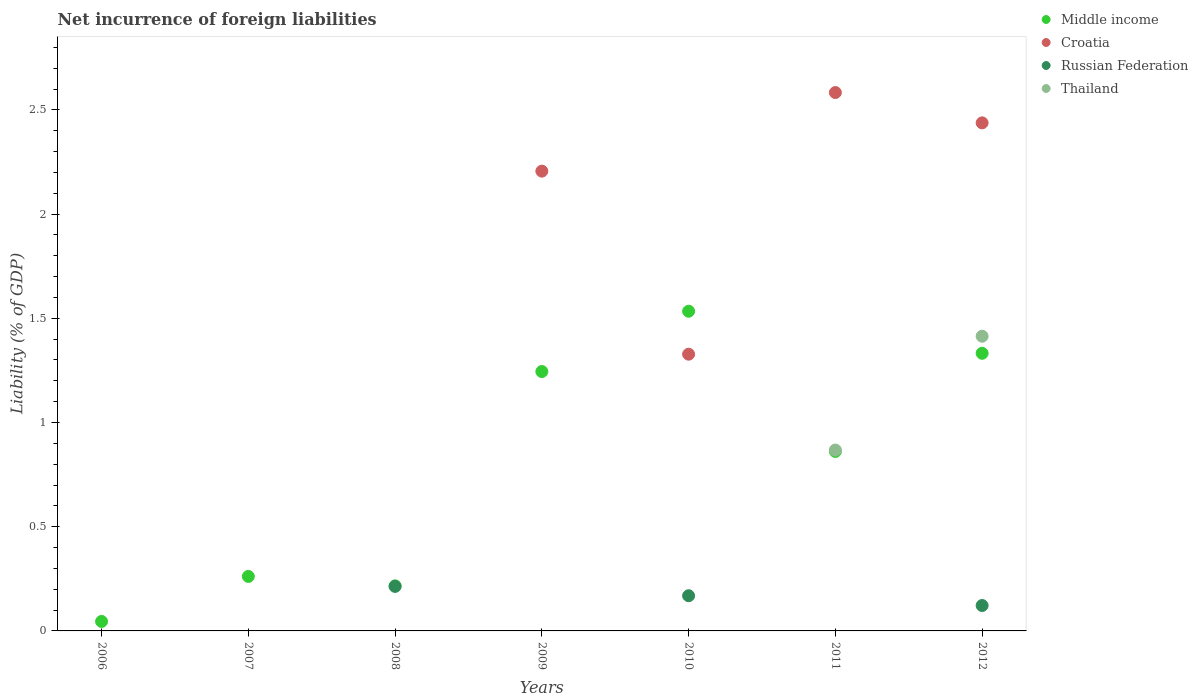What is the net incurrence of foreign liabilities in Thailand in 2011?
Offer a very short reply. 0.87. Across all years, what is the maximum net incurrence of foreign liabilities in Middle income?
Offer a very short reply. 1.53. In which year was the net incurrence of foreign liabilities in Thailand maximum?
Offer a terse response. 2012. What is the total net incurrence of foreign liabilities in Russian Federation in the graph?
Your answer should be compact. 0.5. What is the difference between the net incurrence of foreign liabilities in Middle income in 2008 and that in 2011?
Offer a very short reply. -0.65. What is the difference between the net incurrence of foreign liabilities in Thailand in 2011 and the net incurrence of foreign liabilities in Russian Federation in 2007?
Provide a succinct answer. 0.87. What is the average net incurrence of foreign liabilities in Middle income per year?
Offer a terse response. 0.79. In the year 2010, what is the difference between the net incurrence of foreign liabilities in Croatia and net incurrence of foreign liabilities in Middle income?
Give a very brief answer. -0.21. What is the ratio of the net incurrence of foreign liabilities in Croatia in 2009 to that in 2010?
Provide a succinct answer. 1.66. Is the difference between the net incurrence of foreign liabilities in Croatia in 2010 and 2012 greater than the difference between the net incurrence of foreign liabilities in Middle income in 2010 and 2012?
Your answer should be compact. No. What is the difference between the highest and the second highest net incurrence of foreign liabilities in Croatia?
Your response must be concise. 0.15. What is the difference between the highest and the lowest net incurrence of foreign liabilities in Thailand?
Your answer should be very brief. 1.41. In how many years, is the net incurrence of foreign liabilities in Russian Federation greater than the average net incurrence of foreign liabilities in Russian Federation taken over all years?
Make the answer very short. 3. Is it the case that in every year, the sum of the net incurrence of foreign liabilities in Thailand and net incurrence of foreign liabilities in Croatia  is greater than the sum of net incurrence of foreign liabilities in Middle income and net incurrence of foreign liabilities in Russian Federation?
Provide a short and direct response. No. Does the net incurrence of foreign liabilities in Russian Federation monotonically increase over the years?
Keep it short and to the point. No. Is the net incurrence of foreign liabilities in Middle income strictly greater than the net incurrence of foreign liabilities in Croatia over the years?
Your answer should be compact. No. How many dotlines are there?
Ensure brevity in your answer.  4. What is the difference between two consecutive major ticks on the Y-axis?
Your answer should be compact. 0.5. Are the values on the major ticks of Y-axis written in scientific E-notation?
Your response must be concise. No. Does the graph contain any zero values?
Provide a succinct answer. Yes. Where does the legend appear in the graph?
Keep it short and to the point. Top right. How many legend labels are there?
Keep it short and to the point. 4. What is the title of the graph?
Provide a succinct answer. Net incurrence of foreign liabilities. What is the label or title of the X-axis?
Ensure brevity in your answer.  Years. What is the label or title of the Y-axis?
Keep it short and to the point. Liability (% of GDP). What is the Liability (% of GDP) of Middle income in 2006?
Your answer should be compact. 0.05. What is the Liability (% of GDP) in Middle income in 2007?
Provide a short and direct response. 0.26. What is the Liability (% of GDP) of Thailand in 2007?
Provide a short and direct response. 0. What is the Liability (% of GDP) of Middle income in 2008?
Your answer should be compact. 0.22. What is the Liability (% of GDP) of Croatia in 2008?
Ensure brevity in your answer.  0. What is the Liability (% of GDP) of Russian Federation in 2008?
Make the answer very short. 0.21. What is the Liability (% of GDP) of Middle income in 2009?
Keep it short and to the point. 1.24. What is the Liability (% of GDP) in Croatia in 2009?
Keep it short and to the point. 2.21. What is the Liability (% of GDP) of Russian Federation in 2009?
Your response must be concise. 0. What is the Liability (% of GDP) of Thailand in 2009?
Your answer should be compact. 0. What is the Liability (% of GDP) in Middle income in 2010?
Give a very brief answer. 1.53. What is the Liability (% of GDP) of Croatia in 2010?
Keep it short and to the point. 1.33. What is the Liability (% of GDP) in Russian Federation in 2010?
Offer a very short reply. 0.17. What is the Liability (% of GDP) in Thailand in 2010?
Make the answer very short. 0. What is the Liability (% of GDP) in Middle income in 2011?
Ensure brevity in your answer.  0.86. What is the Liability (% of GDP) of Croatia in 2011?
Your response must be concise. 2.58. What is the Liability (% of GDP) in Russian Federation in 2011?
Offer a terse response. 0. What is the Liability (% of GDP) of Thailand in 2011?
Offer a very short reply. 0.87. What is the Liability (% of GDP) in Middle income in 2012?
Your answer should be compact. 1.33. What is the Liability (% of GDP) of Croatia in 2012?
Offer a very short reply. 2.44. What is the Liability (% of GDP) in Russian Federation in 2012?
Provide a short and direct response. 0.12. What is the Liability (% of GDP) in Thailand in 2012?
Provide a short and direct response. 1.41. Across all years, what is the maximum Liability (% of GDP) in Middle income?
Provide a short and direct response. 1.53. Across all years, what is the maximum Liability (% of GDP) of Croatia?
Make the answer very short. 2.58. Across all years, what is the maximum Liability (% of GDP) in Russian Federation?
Offer a very short reply. 0.21. Across all years, what is the maximum Liability (% of GDP) of Thailand?
Ensure brevity in your answer.  1.41. Across all years, what is the minimum Liability (% of GDP) in Middle income?
Provide a succinct answer. 0.05. Across all years, what is the minimum Liability (% of GDP) in Thailand?
Provide a short and direct response. 0. What is the total Liability (% of GDP) in Middle income in the graph?
Offer a very short reply. 5.5. What is the total Liability (% of GDP) of Croatia in the graph?
Make the answer very short. 8.56. What is the total Liability (% of GDP) in Russian Federation in the graph?
Offer a terse response. 0.5. What is the total Liability (% of GDP) in Thailand in the graph?
Keep it short and to the point. 2.28. What is the difference between the Liability (% of GDP) of Middle income in 2006 and that in 2007?
Your answer should be compact. -0.22. What is the difference between the Liability (% of GDP) of Middle income in 2006 and that in 2008?
Make the answer very short. -0.17. What is the difference between the Liability (% of GDP) in Middle income in 2006 and that in 2009?
Your response must be concise. -1.2. What is the difference between the Liability (% of GDP) in Middle income in 2006 and that in 2010?
Your answer should be compact. -1.49. What is the difference between the Liability (% of GDP) in Middle income in 2006 and that in 2011?
Your answer should be compact. -0.82. What is the difference between the Liability (% of GDP) in Middle income in 2006 and that in 2012?
Provide a short and direct response. -1.29. What is the difference between the Liability (% of GDP) of Middle income in 2007 and that in 2008?
Offer a very short reply. 0.05. What is the difference between the Liability (% of GDP) in Middle income in 2007 and that in 2009?
Offer a very short reply. -0.98. What is the difference between the Liability (% of GDP) of Middle income in 2007 and that in 2010?
Your answer should be compact. -1.27. What is the difference between the Liability (% of GDP) of Middle income in 2007 and that in 2011?
Your answer should be compact. -0.6. What is the difference between the Liability (% of GDP) of Middle income in 2007 and that in 2012?
Your answer should be compact. -1.07. What is the difference between the Liability (% of GDP) of Middle income in 2008 and that in 2009?
Your answer should be very brief. -1.03. What is the difference between the Liability (% of GDP) of Middle income in 2008 and that in 2010?
Provide a short and direct response. -1.32. What is the difference between the Liability (% of GDP) of Russian Federation in 2008 and that in 2010?
Provide a short and direct response. 0.04. What is the difference between the Liability (% of GDP) in Middle income in 2008 and that in 2011?
Your answer should be compact. -0.65. What is the difference between the Liability (% of GDP) in Middle income in 2008 and that in 2012?
Your answer should be compact. -1.12. What is the difference between the Liability (% of GDP) of Russian Federation in 2008 and that in 2012?
Ensure brevity in your answer.  0.09. What is the difference between the Liability (% of GDP) of Middle income in 2009 and that in 2010?
Ensure brevity in your answer.  -0.29. What is the difference between the Liability (% of GDP) in Croatia in 2009 and that in 2010?
Offer a very short reply. 0.88. What is the difference between the Liability (% of GDP) in Middle income in 2009 and that in 2011?
Offer a terse response. 0.38. What is the difference between the Liability (% of GDP) of Croatia in 2009 and that in 2011?
Give a very brief answer. -0.38. What is the difference between the Liability (% of GDP) of Middle income in 2009 and that in 2012?
Make the answer very short. -0.09. What is the difference between the Liability (% of GDP) in Croatia in 2009 and that in 2012?
Keep it short and to the point. -0.23. What is the difference between the Liability (% of GDP) of Middle income in 2010 and that in 2011?
Offer a terse response. 0.67. What is the difference between the Liability (% of GDP) in Croatia in 2010 and that in 2011?
Offer a terse response. -1.26. What is the difference between the Liability (% of GDP) of Middle income in 2010 and that in 2012?
Your answer should be compact. 0.2. What is the difference between the Liability (% of GDP) in Croatia in 2010 and that in 2012?
Your response must be concise. -1.11. What is the difference between the Liability (% of GDP) in Russian Federation in 2010 and that in 2012?
Your answer should be compact. 0.05. What is the difference between the Liability (% of GDP) in Middle income in 2011 and that in 2012?
Offer a terse response. -0.47. What is the difference between the Liability (% of GDP) of Croatia in 2011 and that in 2012?
Your answer should be very brief. 0.15. What is the difference between the Liability (% of GDP) of Thailand in 2011 and that in 2012?
Keep it short and to the point. -0.55. What is the difference between the Liability (% of GDP) in Middle income in 2006 and the Liability (% of GDP) in Russian Federation in 2008?
Your answer should be compact. -0.17. What is the difference between the Liability (% of GDP) in Middle income in 2006 and the Liability (% of GDP) in Croatia in 2009?
Offer a very short reply. -2.16. What is the difference between the Liability (% of GDP) in Middle income in 2006 and the Liability (% of GDP) in Croatia in 2010?
Keep it short and to the point. -1.28. What is the difference between the Liability (% of GDP) in Middle income in 2006 and the Liability (% of GDP) in Russian Federation in 2010?
Keep it short and to the point. -0.12. What is the difference between the Liability (% of GDP) of Middle income in 2006 and the Liability (% of GDP) of Croatia in 2011?
Ensure brevity in your answer.  -2.54. What is the difference between the Liability (% of GDP) in Middle income in 2006 and the Liability (% of GDP) in Thailand in 2011?
Your answer should be very brief. -0.82. What is the difference between the Liability (% of GDP) of Middle income in 2006 and the Liability (% of GDP) of Croatia in 2012?
Your answer should be compact. -2.39. What is the difference between the Liability (% of GDP) of Middle income in 2006 and the Liability (% of GDP) of Russian Federation in 2012?
Provide a succinct answer. -0.08. What is the difference between the Liability (% of GDP) of Middle income in 2006 and the Liability (% of GDP) of Thailand in 2012?
Give a very brief answer. -1.37. What is the difference between the Liability (% of GDP) in Middle income in 2007 and the Liability (% of GDP) in Russian Federation in 2008?
Provide a short and direct response. 0.05. What is the difference between the Liability (% of GDP) in Middle income in 2007 and the Liability (% of GDP) in Croatia in 2009?
Your answer should be compact. -1.94. What is the difference between the Liability (% of GDP) in Middle income in 2007 and the Liability (% of GDP) in Croatia in 2010?
Give a very brief answer. -1.07. What is the difference between the Liability (% of GDP) in Middle income in 2007 and the Liability (% of GDP) in Russian Federation in 2010?
Your response must be concise. 0.09. What is the difference between the Liability (% of GDP) of Middle income in 2007 and the Liability (% of GDP) of Croatia in 2011?
Keep it short and to the point. -2.32. What is the difference between the Liability (% of GDP) of Middle income in 2007 and the Liability (% of GDP) of Thailand in 2011?
Keep it short and to the point. -0.61. What is the difference between the Liability (% of GDP) of Middle income in 2007 and the Liability (% of GDP) of Croatia in 2012?
Provide a short and direct response. -2.18. What is the difference between the Liability (% of GDP) in Middle income in 2007 and the Liability (% of GDP) in Russian Federation in 2012?
Your answer should be compact. 0.14. What is the difference between the Liability (% of GDP) in Middle income in 2007 and the Liability (% of GDP) in Thailand in 2012?
Make the answer very short. -1.15. What is the difference between the Liability (% of GDP) of Middle income in 2008 and the Liability (% of GDP) of Croatia in 2009?
Give a very brief answer. -1.99. What is the difference between the Liability (% of GDP) in Middle income in 2008 and the Liability (% of GDP) in Croatia in 2010?
Offer a very short reply. -1.11. What is the difference between the Liability (% of GDP) of Middle income in 2008 and the Liability (% of GDP) of Russian Federation in 2010?
Offer a terse response. 0.05. What is the difference between the Liability (% of GDP) of Middle income in 2008 and the Liability (% of GDP) of Croatia in 2011?
Your answer should be compact. -2.37. What is the difference between the Liability (% of GDP) in Middle income in 2008 and the Liability (% of GDP) in Thailand in 2011?
Keep it short and to the point. -0.65. What is the difference between the Liability (% of GDP) in Russian Federation in 2008 and the Liability (% of GDP) in Thailand in 2011?
Keep it short and to the point. -0.65. What is the difference between the Liability (% of GDP) in Middle income in 2008 and the Liability (% of GDP) in Croatia in 2012?
Provide a succinct answer. -2.22. What is the difference between the Liability (% of GDP) of Middle income in 2008 and the Liability (% of GDP) of Russian Federation in 2012?
Keep it short and to the point. 0.09. What is the difference between the Liability (% of GDP) in Middle income in 2008 and the Liability (% of GDP) in Thailand in 2012?
Your response must be concise. -1.2. What is the difference between the Liability (% of GDP) of Russian Federation in 2008 and the Liability (% of GDP) of Thailand in 2012?
Your answer should be very brief. -1.2. What is the difference between the Liability (% of GDP) in Middle income in 2009 and the Liability (% of GDP) in Croatia in 2010?
Make the answer very short. -0.08. What is the difference between the Liability (% of GDP) of Middle income in 2009 and the Liability (% of GDP) of Russian Federation in 2010?
Your answer should be very brief. 1.08. What is the difference between the Liability (% of GDP) in Croatia in 2009 and the Liability (% of GDP) in Russian Federation in 2010?
Offer a terse response. 2.04. What is the difference between the Liability (% of GDP) in Middle income in 2009 and the Liability (% of GDP) in Croatia in 2011?
Keep it short and to the point. -1.34. What is the difference between the Liability (% of GDP) in Middle income in 2009 and the Liability (% of GDP) in Thailand in 2011?
Provide a short and direct response. 0.38. What is the difference between the Liability (% of GDP) of Croatia in 2009 and the Liability (% of GDP) of Thailand in 2011?
Ensure brevity in your answer.  1.34. What is the difference between the Liability (% of GDP) in Middle income in 2009 and the Liability (% of GDP) in Croatia in 2012?
Your response must be concise. -1.19. What is the difference between the Liability (% of GDP) in Middle income in 2009 and the Liability (% of GDP) in Russian Federation in 2012?
Ensure brevity in your answer.  1.12. What is the difference between the Liability (% of GDP) in Middle income in 2009 and the Liability (% of GDP) in Thailand in 2012?
Provide a short and direct response. -0.17. What is the difference between the Liability (% of GDP) in Croatia in 2009 and the Liability (% of GDP) in Russian Federation in 2012?
Your answer should be compact. 2.08. What is the difference between the Liability (% of GDP) in Croatia in 2009 and the Liability (% of GDP) in Thailand in 2012?
Your answer should be very brief. 0.79. What is the difference between the Liability (% of GDP) in Middle income in 2010 and the Liability (% of GDP) in Croatia in 2011?
Give a very brief answer. -1.05. What is the difference between the Liability (% of GDP) of Middle income in 2010 and the Liability (% of GDP) of Thailand in 2011?
Your answer should be compact. 0.67. What is the difference between the Liability (% of GDP) of Croatia in 2010 and the Liability (% of GDP) of Thailand in 2011?
Make the answer very short. 0.46. What is the difference between the Liability (% of GDP) of Russian Federation in 2010 and the Liability (% of GDP) of Thailand in 2011?
Provide a succinct answer. -0.7. What is the difference between the Liability (% of GDP) of Middle income in 2010 and the Liability (% of GDP) of Croatia in 2012?
Make the answer very short. -0.9. What is the difference between the Liability (% of GDP) of Middle income in 2010 and the Liability (% of GDP) of Russian Federation in 2012?
Your answer should be compact. 1.41. What is the difference between the Liability (% of GDP) in Middle income in 2010 and the Liability (% of GDP) in Thailand in 2012?
Give a very brief answer. 0.12. What is the difference between the Liability (% of GDP) in Croatia in 2010 and the Liability (% of GDP) in Russian Federation in 2012?
Keep it short and to the point. 1.21. What is the difference between the Liability (% of GDP) in Croatia in 2010 and the Liability (% of GDP) in Thailand in 2012?
Give a very brief answer. -0.09. What is the difference between the Liability (% of GDP) of Russian Federation in 2010 and the Liability (% of GDP) of Thailand in 2012?
Provide a succinct answer. -1.25. What is the difference between the Liability (% of GDP) of Middle income in 2011 and the Liability (% of GDP) of Croatia in 2012?
Offer a terse response. -1.58. What is the difference between the Liability (% of GDP) of Middle income in 2011 and the Liability (% of GDP) of Russian Federation in 2012?
Provide a short and direct response. 0.74. What is the difference between the Liability (% of GDP) of Middle income in 2011 and the Liability (% of GDP) of Thailand in 2012?
Your response must be concise. -0.55. What is the difference between the Liability (% of GDP) in Croatia in 2011 and the Liability (% of GDP) in Russian Federation in 2012?
Your answer should be compact. 2.46. What is the difference between the Liability (% of GDP) in Croatia in 2011 and the Liability (% of GDP) in Thailand in 2012?
Offer a very short reply. 1.17. What is the average Liability (% of GDP) of Middle income per year?
Your answer should be compact. 0.79. What is the average Liability (% of GDP) of Croatia per year?
Your response must be concise. 1.22. What is the average Liability (% of GDP) of Russian Federation per year?
Keep it short and to the point. 0.07. What is the average Liability (% of GDP) in Thailand per year?
Ensure brevity in your answer.  0.33. In the year 2008, what is the difference between the Liability (% of GDP) in Middle income and Liability (% of GDP) in Russian Federation?
Provide a short and direct response. 0. In the year 2009, what is the difference between the Liability (% of GDP) in Middle income and Liability (% of GDP) in Croatia?
Provide a succinct answer. -0.96. In the year 2010, what is the difference between the Liability (% of GDP) of Middle income and Liability (% of GDP) of Croatia?
Provide a succinct answer. 0.21. In the year 2010, what is the difference between the Liability (% of GDP) of Middle income and Liability (% of GDP) of Russian Federation?
Keep it short and to the point. 1.37. In the year 2010, what is the difference between the Liability (% of GDP) in Croatia and Liability (% of GDP) in Russian Federation?
Your response must be concise. 1.16. In the year 2011, what is the difference between the Liability (% of GDP) of Middle income and Liability (% of GDP) of Croatia?
Make the answer very short. -1.72. In the year 2011, what is the difference between the Liability (% of GDP) in Middle income and Liability (% of GDP) in Thailand?
Your answer should be very brief. -0.01. In the year 2011, what is the difference between the Liability (% of GDP) in Croatia and Liability (% of GDP) in Thailand?
Your answer should be very brief. 1.72. In the year 2012, what is the difference between the Liability (% of GDP) of Middle income and Liability (% of GDP) of Croatia?
Provide a short and direct response. -1.11. In the year 2012, what is the difference between the Liability (% of GDP) in Middle income and Liability (% of GDP) in Russian Federation?
Provide a succinct answer. 1.21. In the year 2012, what is the difference between the Liability (% of GDP) in Middle income and Liability (% of GDP) in Thailand?
Make the answer very short. -0.08. In the year 2012, what is the difference between the Liability (% of GDP) of Croatia and Liability (% of GDP) of Russian Federation?
Give a very brief answer. 2.32. In the year 2012, what is the difference between the Liability (% of GDP) of Croatia and Liability (% of GDP) of Thailand?
Your answer should be very brief. 1.02. In the year 2012, what is the difference between the Liability (% of GDP) in Russian Federation and Liability (% of GDP) in Thailand?
Offer a terse response. -1.29. What is the ratio of the Liability (% of GDP) in Middle income in 2006 to that in 2007?
Provide a succinct answer. 0.17. What is the ratio of the Liability (% of GDP) in Middle income in 2006 to that in 2008?
Provide a succinct answer. 0.21. What is the ratio of the Liability (% of GDP) of Middle income in 2006 to that in 2009?
Keep it short and to the point. 0.04. What is the ratio of the Liability (% of GDP) of Middle income in 2006 to that in 2010?
Keep it short and to the point. 0.03. What is the ratio of the Liability (% of GDP) of Middle income in 2006 to that in 2011?
Make the answer very short. 0.05. What is the ratio of the Liability (% of GDP) of Middle income in 2006 to that in 2012?
Make the answer very short. 0.03. What is the ratio of the Liability (% of GDP) in Middle income in 2007 to that in 2008?
Provide a short and direct response. 1.21. What is the ratio of the Liability (% of GDP) of Middle income in 2007 to that in 2009?
Make the answer very short. 0.21. What is the ratio of the Liability (% of GDP) of Middle income in 2007 to that in 2010?
Provide a succinct answer. 0.17. What is the ratio of the Liability (% of GDP) of Middle income in 2007 to that in 2011?
Ensure brevity in your answer.  0.3. What is the ratio of the Liability (% of GDP) in Middle income in 2007 to that in 2012?
Make the answer very short. 0.2. What is the ratio of the Liability (% of GDP) in Middle income in 2008 to that in 2009?
Offer a terse response. 0.17. What is the ratio of the Liability (% of GDP) in Middle income in 2008 to that in 2010?
Give a very brief answer. 0.14. What is the ratio of the Liability (% of GDP) of Russian Federation in 2008 to that in 2010?
Make the answer very short. 1.27. What is the ratio of the Liability (% of GDP) in Middle income in 2008 to that in 2011?
Give a very brief answer. 0.25. What is the ratio of the Liability (% of GDP) in Middle income in 2008 to that in 2012?
Your response must be concise. 0.16. What is the ratio of the Liability (% of GDP) in Russian Federation in 2008 to that in 2012?
Offer a very short reply. 1.75. What is the ratio of the Liability (% of GDP) in Middle income in 2009 to that in 2010?
Offer a very short reply. 0.81. What is the ratio of the Liability (% of GDP) of Croatia in 2009 to that in 2010?
Offer a very short reply. 1.66. What is the ratio of the Liability (% of GDP) in Middle income in 2009 to that in 2011?
Your answer should be compact. 1.45. What is the ratio of the Liability (% of GDP) of Croatia in 2009 to that in 2011?
Provide a succinct answer. 0.85. What is the ratio of the Liability (% of GDP) of Middle income in 2009 to that in 2012?
Offer a terse response. 0.93. What is the ratio of the Liability (% of GDP) of Croatia in 2009 to that in 2012?
Keep it short and to the point. 0.91. What is the ratio of the Liability (% of GDP) in Middle income in 2010 to that in 2011?
Offer a very short reply. 1.78. What is the ratio of the Liability (% of GDP) of Croatia in 2010 to that in 2011?
Provide a short and direct response. 0.51. What is the ratio of the Liability (% of GDP) of Middle income in 2010 to that in 2012?
Make the answer very short. 1.15. What is the ratio of the Liability (% of GDP) of Croatia in 2010 to that in 2012?
Give a very brief answer. 0.54. What is the ratio of the Liability (% of GDP) in Russian Federation in 2010 to that in 2012?
Give a very brief answer. 1.39. What is the ratio of the Liability (% of GDP) in Middle income in 2011 to that in 2012?
Provide a succinct answer. 0.65. What is the ratio of the Liability (% of GDP) in Croatia in 2011 to that in 2012?
Make the answer very short. 1.06. What is the ratio of the Liability (% of GDP) of Thailand in 2011 to that in 2012?
Offer a terse response. 0.61. What is the difference between the highest and the second highest Liability (% of GDP) of Middle income?
Ensure brevity in your answer.  0.2. What is the difference between the highest and the second highest Liability (% of GDP) in Croatia?
Ensure brevity in your answer.  0.15. What is the difference between the highest and the second highest Liability (% of GDP) of Russian Federation?
Offer a very short reply. 0.04. What is the difference between the highest and the lowest Liability (% of GDP) of Middle income?
Offer a terse response. 1.49. What is the difference between the highest and the lowest Liability (% of GDP) of Croatia?
Make the answer very short. 2.58. What is the difference between the highest and the lowest Liability (% of GDP) in Russian Federation?
Provide a succinct answer. 0.21. What is the difference between the highest and the lowest Liability (% of GDP) of Thailand?
Your answer should be very brief. 1.41. 